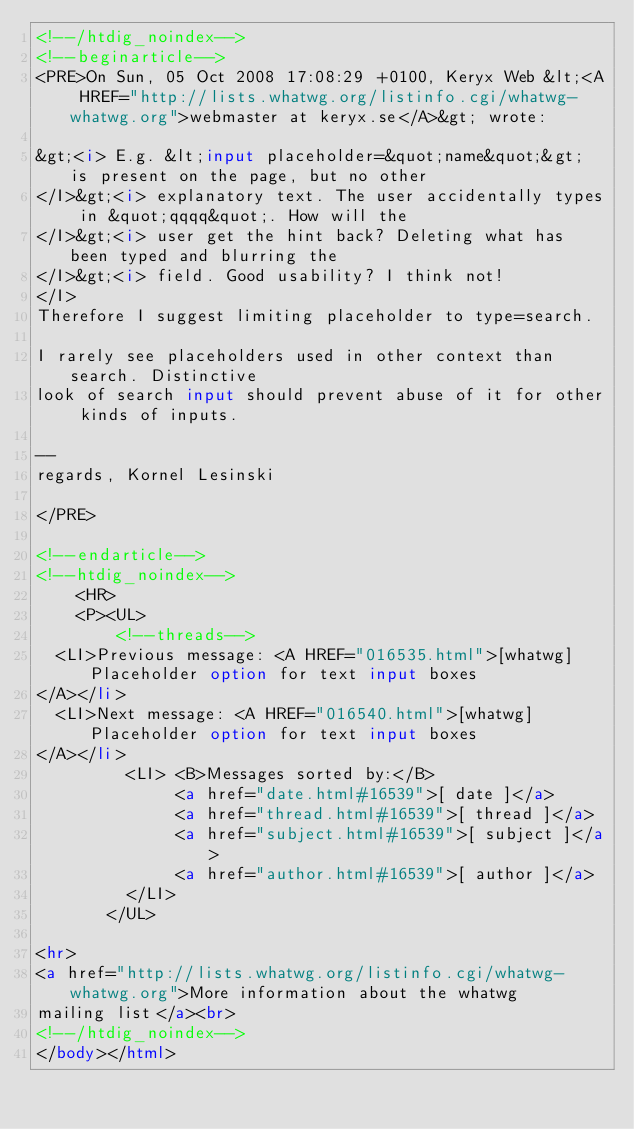<code> <loc_0><loc_0><loc_500><loc_500><_HTML_><!--/htdig_noindex-->
<!--beginarticle-->
<PRE>On Sun, 05 Oct 2008 17:08:29 +0100, Keryx Web &lt;<A HREF="http://lists.whatwg.org/listinfo.cgi/whatwg-whatwg.org">webmaster at keryx.se</A>&gt; wrote:

&gt;<i> E.g. &lt;input placeholder=&quot;name&quot;&gt; is present on the page, but no other  
</I>&gt;<i> explanatory text. The user accidentally types in &quot;qqqq&quot;. How will the  
</I>&gt;<i> user get the hint back? Deleting what has been typed and blurring the  
</I>&gt;<i> field. Good usability? I think not!
</I>
Therefore I suggest limiting placeholder to type=search.

I rarely see placeholders used in other context than search. Distinctive  
look of search input should prevent abuse of it for other kinds of inputs.

-- 
regards, Kornel Lesinski

</PRE>

<!--endarticle-->
<!--htdig_noindex-->
    <HR>
    <P><UL>
        <!--threads-->
	<LI>Previous message: <A HREF="016535.html">[whatwg] Placeholder option for text input boxes
</A></li>
	<LI>Next message: <A HREF="016540.html">[whatwg] Placeholder option for text input boxes
</A></li>
         <LI> <B>Messages sorted by:</B> 
              <a href="date.html#16539">[ date ]</a>
              <a href="thread.html#16539">[ thread ]</a>
              <a href="subject.html#16539">[ subject ]</a>
              <a href="author.html#16539">[ author ]</a>
         </LI>
       </UL>

<hr>
<a href="http://lists.whatwg.org/listinfo.cgi/whatwg-whatwg.org">More information about the whatwg
mailing list</a><br>
<!--/htdig_noindex-->
</body></html>
</code> 